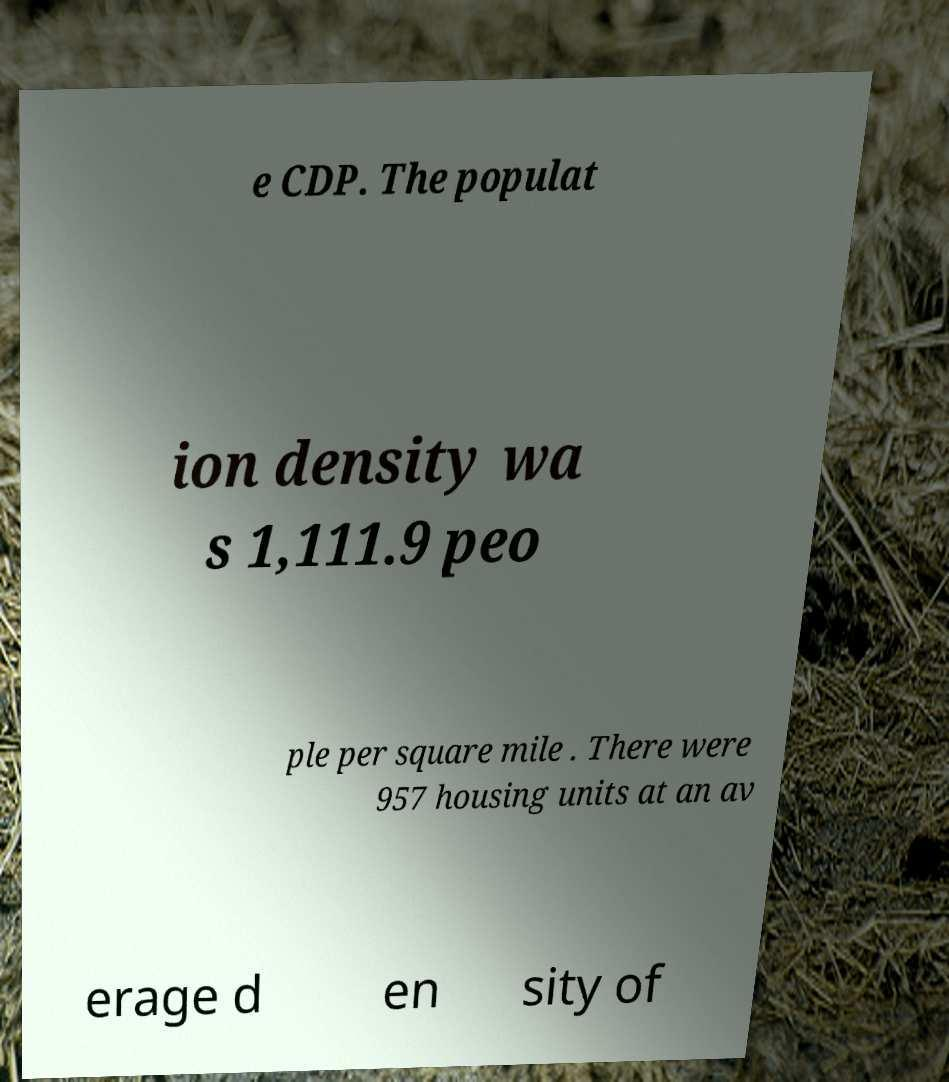There's text embedded in this image that I need extracted. Can you transcribe it verbatim? e CDP. The populat ion density wa s 1,111.9 peo ple per square mile . There were 957 housing units at an av erage d en sity of 